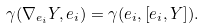Convert formula to latex. <formula><loc_0><loc_0><loc_500><loc_500>\gamma ( \nabla _ { e _ { i } } Y , e _ { i } ) = \gamma ( e _ { i } , [ e _ { i } , Y ] ) .</formula> 